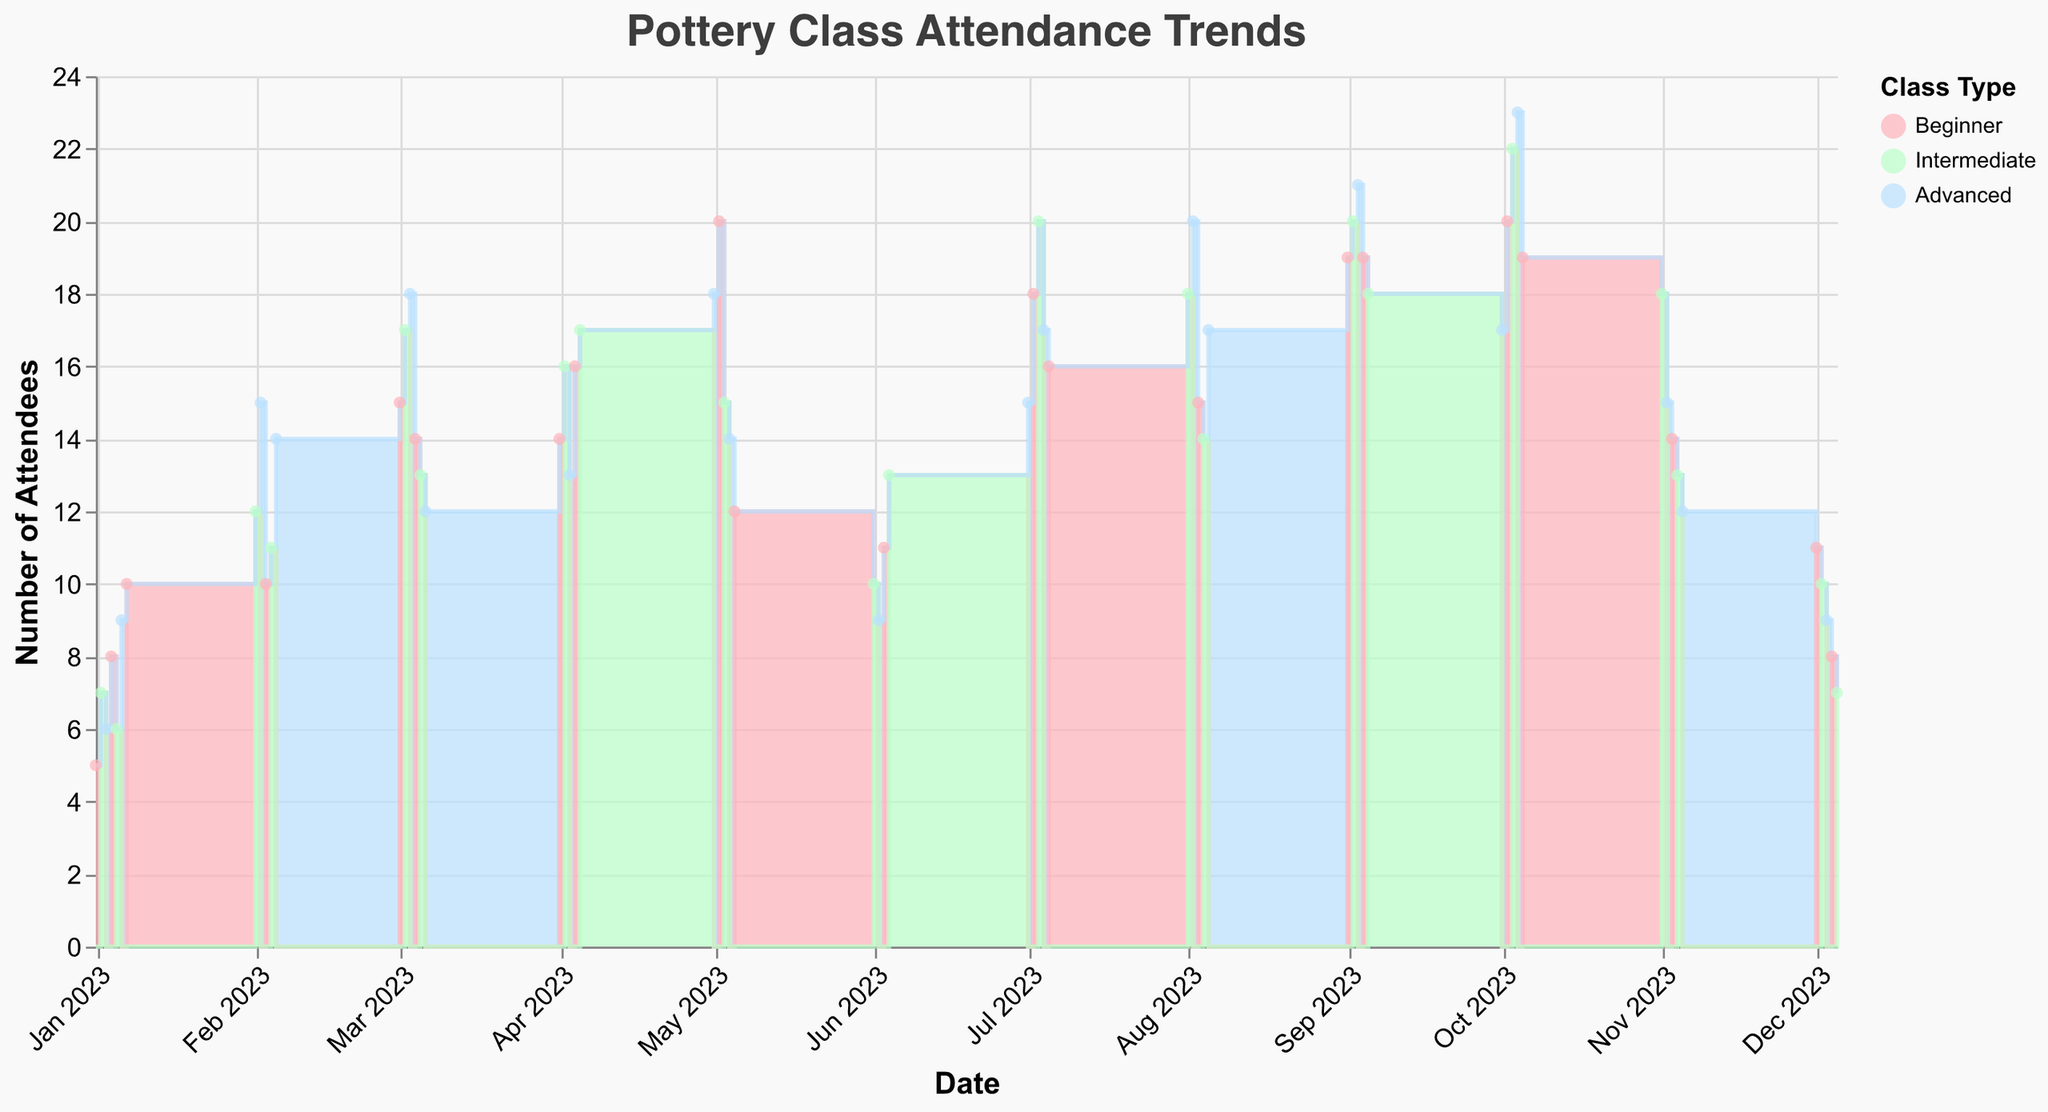What's the title of the chart? The title of the chart can be seen at the top of the figure: "Pottery Class Attendance Trends"
Answer: Pottery Class Attendance Trends During which month did the Beginner class have the highest attendance? The Beginner class had the highest number of attendees on October 2nd with 20 attendees
Answer: October Which class type had the highest attendance in September? The highest attendance in September was in the Advanced class on September 3rd with 21 attendees
Answer: Advanced How many attendees were there in Intermediate classes on January 2nd and July 3rd combined? On January 2nd, there were 7 attendees and on July 3rd, there were 20 attendees. Summing them gives 7 + 20 = 27
Answer: 27 Compare the attendance for Advanced classes in August and October. Which month had a higher attendance? For Advanced classes, August had 17 attendees on August 5th, while October had 23 attendees on October 4th. October had a higher attendance
Answer: October What is the trend of attendance for Advanced classes from February to April? Advanced class attendance decreases from February (15) to March (12) and slightly rises in April (13)
Answer: Decreasing How did the overall attendance trend for Beginner classes change from March to December? Beginner class attendance saw fluctuations, peaking in July at 18 and then gradually decreasing with minimum attendance in December being 8
Answer: Fluctuating, then decreasing Which class type shows the most monthly fluctuation in attendance? By visually comparing step-changes, it is noticeable that the Beginner class shows significant monthly fluctuations in attendance
Answer: Beginner 